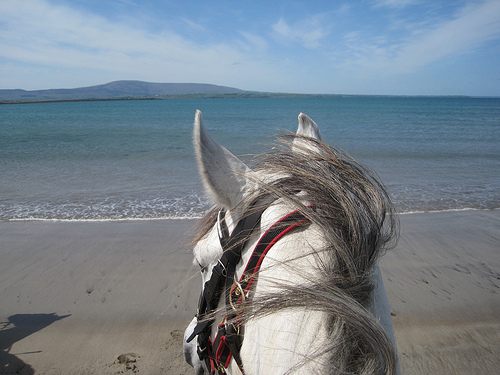<image>
Is there a horse under the water? No. The horse is not positioned under the water. The vertical relationship between these objects is different. 